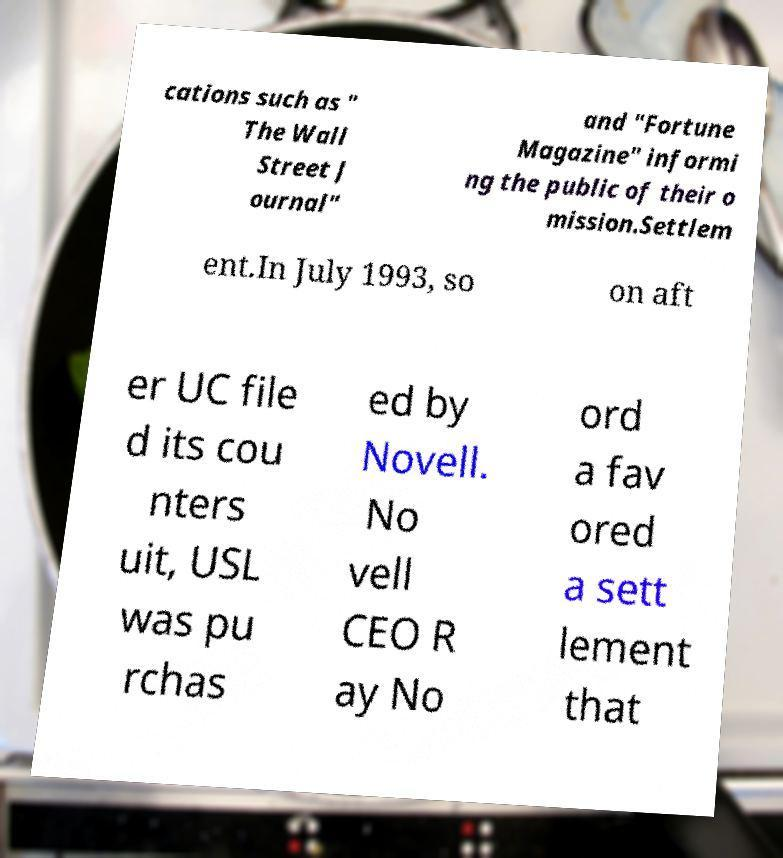Please identify and transcribe the text found in this image. cations such as " The Wall Street J ournal" and "Fortune Magazine" informi ng the public of their o mission.Settlem ent.In July 1993, so on aft er UC file d its cou nters uit, USL was pu rchas ed by Novell. No vell CEO R ay No ord a fav ored a sett lement that 